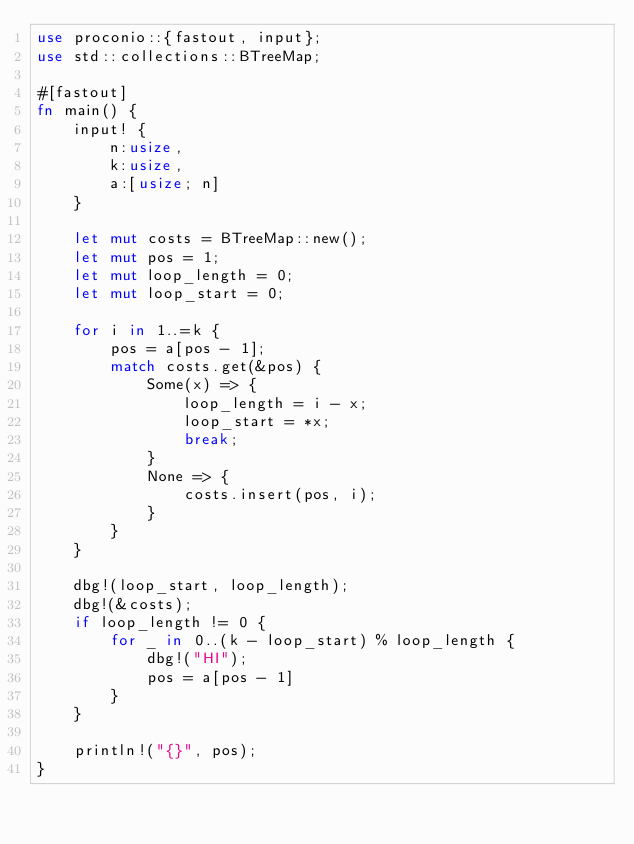<code> <loc_0><loc_0><loc_500><loc_500><_Rust_>use proconio::{fastout, input};
use std::collections::BTreeMap;

#[fastout]
fn main() {
    input! {
        n:usize,
        k:usize,
        a:[usize; n]
    }

    let mut costs = BTreeMap::new();
    let mut pos = 1;
    let mut loop_length = 0;
    let mut loop_start = 0;

    for i in 1..=k {
        pos = a[pos - 1];
        match costs.get(&pos) {
            Some(x) => {
                loop_length = i - x;
                loop_start = *x;
                break;
            }
            None => {
                costs.insert(pos, i);
            }
        }
    }

    dbg!(loop_start, loop_length);
    dbg!(&costs);
    if loop_length != 0 {
        for _ in 0..(k - loop_start) % loop_length {
            dbg!("HI");
            pos = a[pos - 1]
        }
    }

    println!("{}", pos);
}
</code> 